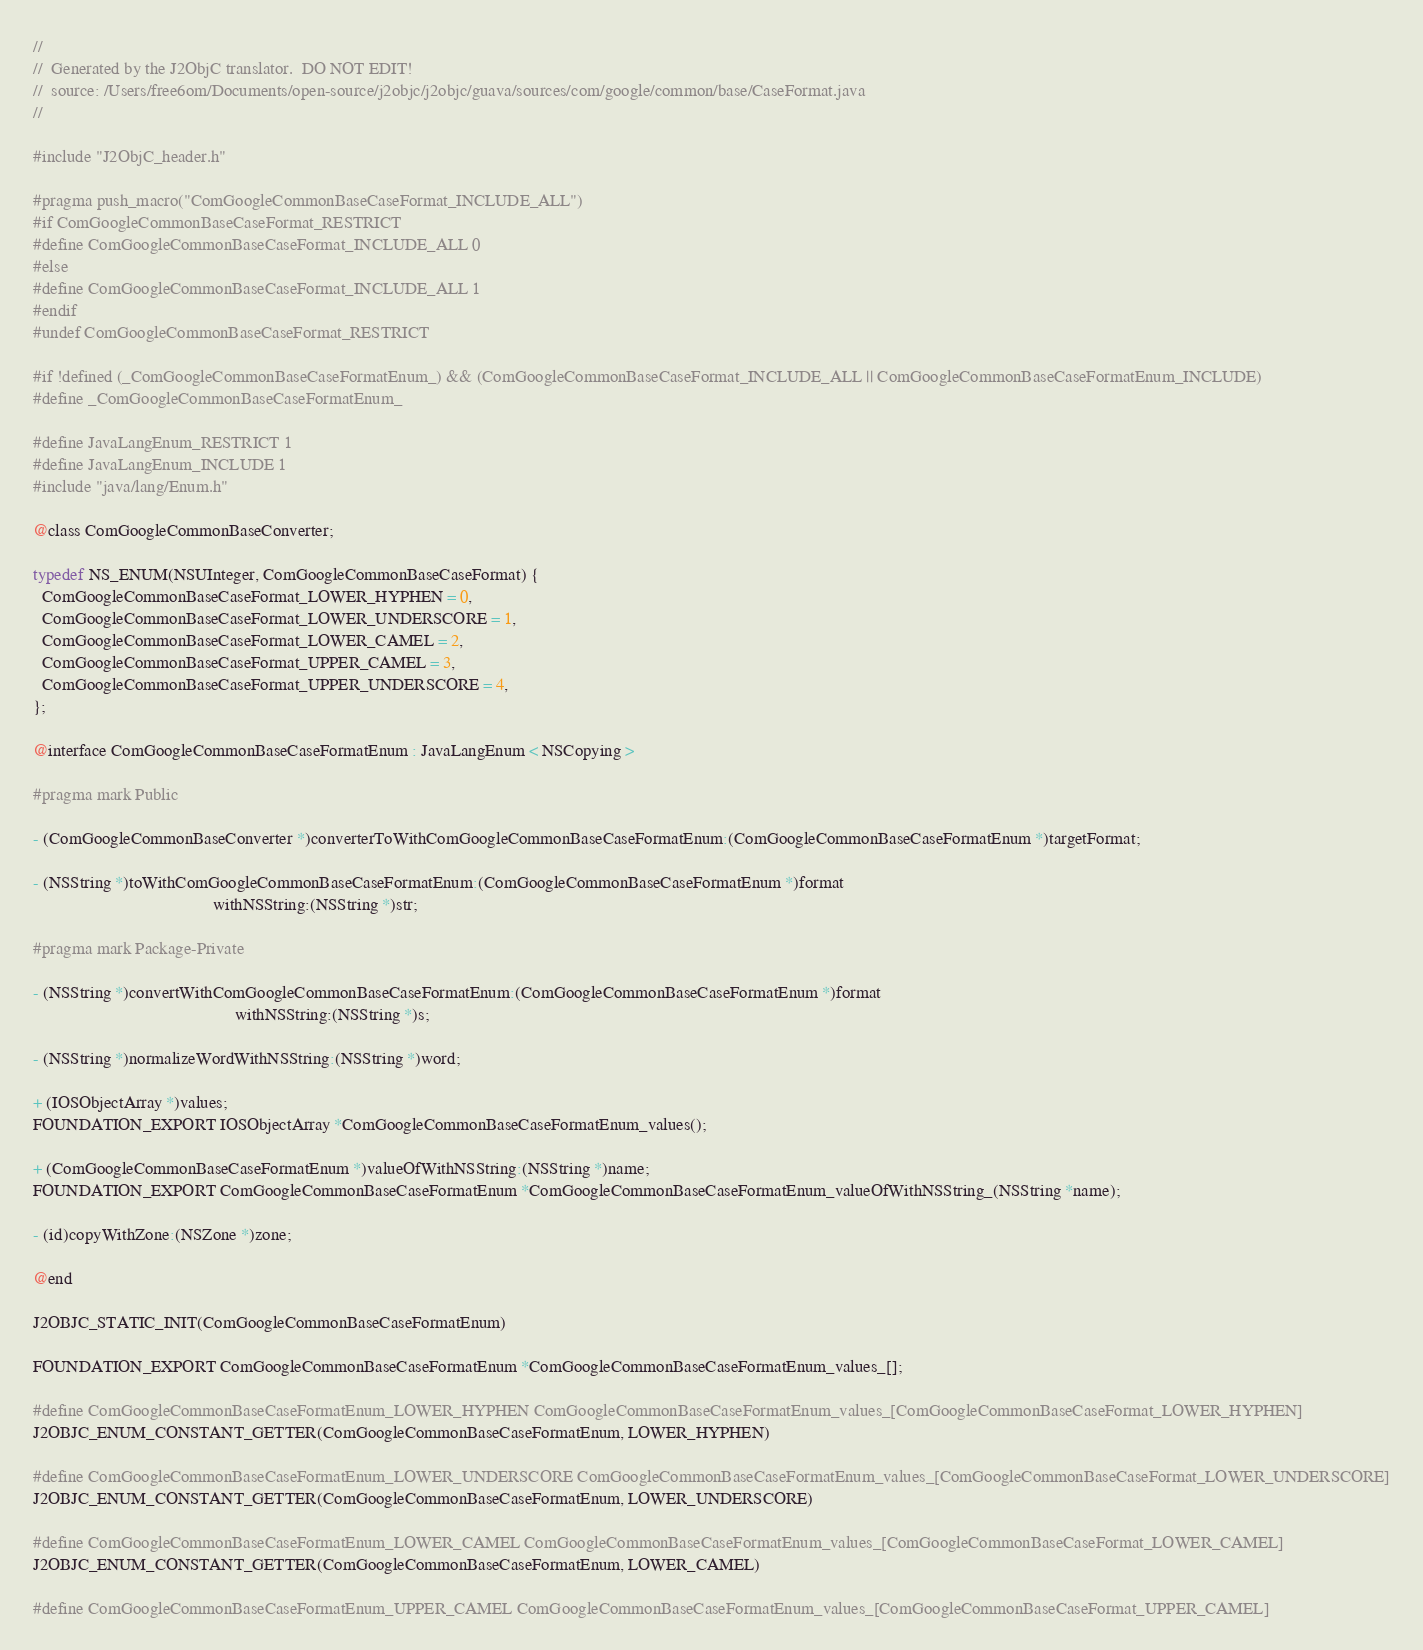Convert code to text. <code><loc_0><loc_0><loc_500><loc_500><_C_>//
//  Generated by the J2ObjC translator.  DO NOT EDIT!
//  source: /Users/free6om/Documents/open-source/j2objc/j2objc/guava/sources/com/google/common/base/CaseFormat.java
//

#include "J2ObjC_header.h"

#pragma push_macro("ComGoogleCommonBaseCaseFormat_INCLUDE_ALL")
#if ComGoogleCommonBaseCaseFormat_RESTRICT
#define ComGoogleCommonBaseCaseFormat_INCLUDE_ALL 0
#else
#define ComGoogleCommonBaseCaseFormat_INCLUDE_ALL 1
#endif
#undef ComGoogleCommonBaseCaseFormat_RESTRICT

#if !defined (_ComGoogleCommonBaseCaseFormatEnum_) && (ComGoogleCommonBaseCaseFormat_INCLUDE_ALL || ComGoogleCommonBaseCaseFormatEnum_INCLUDE)
#define _ComGoogleCommonBaseCaseFormatEnum_

#define JavaLangEnum_RESTRICT 1
#define JavaLangEnum_INCLUDE 1
#include "java/lang/Enum.h"

@class ComGoogleCommonBaseConverter;

typedef NS_ENUM(NSUInteger, ComGoogleCommonBaseCaseFormat) {
  ComGoogleCommonBaseCaseFormat_LOWER_HYPHEN = 0,
  ComGoogleCommonBaseCaseFormat_LOWER_UNDERSCORE = 1,
  ComGoogleCommonBaseCaseFormat_LOWER_CAMEL = 2,
  ComGoogleCommonBaseCaseFormat_UPPER_CAMEL = 3,
  ComGoogleCommonBaseCaseFormat_UPPER_UNDERSCORE = 4,
};

@interface ComGoogleCommonBaseCaseFormatEnum : JavaLangEnum < NSCopying >

#pragma mark Public

- (ComGoogleCommonBaseConverter *)converterToWithComGoogleCommonBaseCaseFormatEnum:(ComGoogleCommonBaseCaseFormatEnum *)targetFormat;

- (NSString *)toWithComGoogleCommonBaseCaseFormatEnum:(ComGoogleCommonBaseCaseFormatEnum *)format
                                         withNSString:(NSString *)str;

#pragma mark Package-Private

- (NSString *)convertWithComGoogleCommonBaseCaseFormatEnum:(ComGoogleCommonBaseCaseFormatEnum *)format
                                              withNSString:(NSString *)s;

- (NSString *)normalizeWordWithNSString:(NSString *)word;

+ (IOSObjectArray *)values;
FOUNDATION_EXPORT IOSObjectArray *ComGoogleCommonBaseCaseFormatEnum_values();

+ (ComGoogleCommonBaseCaseFormatEnum *)valueOfWithNSString:(NSString *)name;
FOUNDATION_EXPORT ComGoogleCommonBaseCaseFormatEnum *ComGoogleCommonBaseCaseFormatEnum_valueOfWithNSString_(NSString *name);

- (id)copyWithZone:(NSZone *)zone;

@end

J2OBJC_STATIC_INIT(ComGoogleCommonBaseCaseFormatEnum)

FOUNDATION_EXPORT ComGoogleCommonBaseCaseFormatEnum *ComGoogleCommonBaseCaseFormatEnum_values_[];

#define ComGoogleCommonBaseCaseFormatEnum_LOWER_HYPHEN ComGoogleCommonBaseCaseFormatEnum_values_[ComGoogleCommonBaseCaseFormat_LOWER_HYPHEN]
J2OBJC_ENUM_CONSTANT_GETTER(ComGoogleCommonBaseCaseFormatEnum, LOWER_HYPHEN)

#define ComGoogleCommonBaseCaseFormatEnum_LOWER_UNDERSCORE ComGoogleCommonBaseCaseFormatEnum_values_[ComGoogleCommonBaseCaseFormat_LOWER_UNDERSCORE]
J2OBJC_ENUM_CONSTANT_GETTER(ComGoogleCommonBaseCaseFormatEnum, LOWER_UNDERSCORE)

#define ComGoogleCommonBaseCaseFormatEnum_LOWER_CAMEL ComGoogleCommonBaseCaseFormatEnum_values_[ComGoogleCommonBaseCaseFormat_LOWER_CAMEL]
J2OBJC_ENUM_CONSTANT_GETTER(ComGoogleCommonBaseCaseFormatEnum, LOWER_CAMEL)

#define ComGoogleCommonBaseCaseFormatEnum_UPPER_CAMEL ComGoogleCommonBaseCaseFormatEnum_values_[ComGoogleCommonBaseCaseFormat_UPPER_CAMEL]</code> 